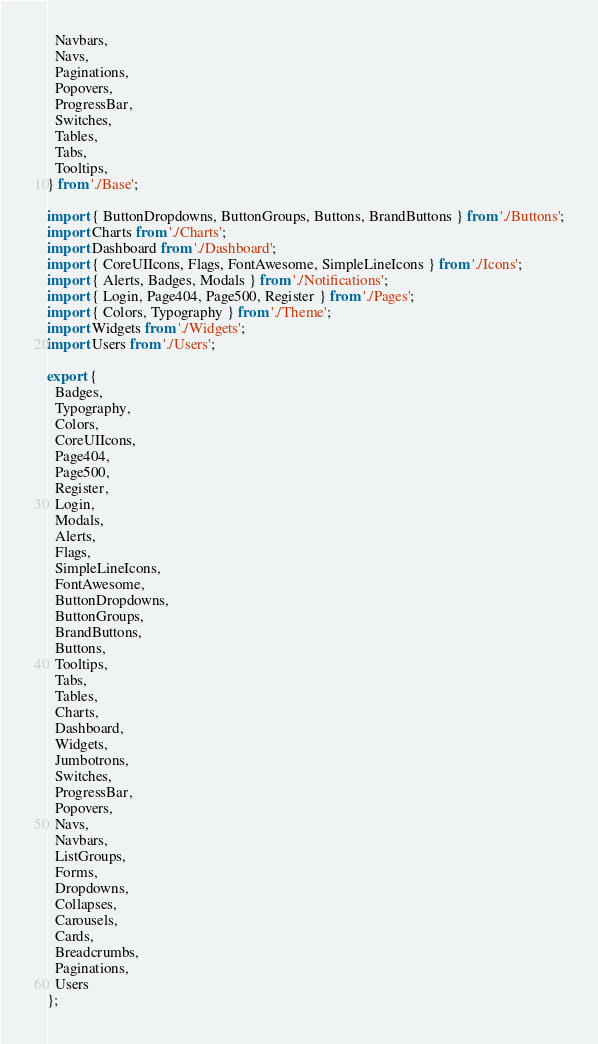<code> <loc_0><loc_0><loc_500><loc_500><_JavaScript_>  Navbars,
  Navs,
  Paginations,
  Popovers,
  ProgressBar,
  Switches,
  Tables,
  Tabs,
  Tooltips,
} from './Base';

import { ButtonDropdowns, ButtonGroups, Buttons, BrandButtons } from './Buttons';
import Charts from './Charts';
import Dashboard from './Dashboard';
import { CoreUIIcons, Flags, FontAwesome, SimpleLineIcons } from './Icons';
import { Alerts, Badges, Modals } from './Notifications';
import { Login, Page404, Page500, Register } from './Pages';
import { Colors, Typography } from './Theme';
import Widgets from './Widgets';
import Users from './Users';

export {
  Badges,
  Typography,
  Colors,
  CoreUIIcons,
  Page404,
  Page500,
  Register,
  Login,
  Modals,
  Alerts,
  Flags,
  SimpleLineIcons,
  FontAwesome,
  ButtonDropdowns,
  ButtonGroups,
  BrandButtons,
  Buttons,
  Tooltips,
  Tabs,
  Tables,
  Charts,
  Dashboard,
  Widgets,
  Jumbotrons,
  Switches,
  ProgressBar,
  Popovers,
  Navs,
  Navbars,
  ListGroups,
  Forms,
  Dropdowns,
  Collapses,
  Carousels,
  Cards,
  Breadcrumbs,
  Paginations,
  Users
};

</code> 